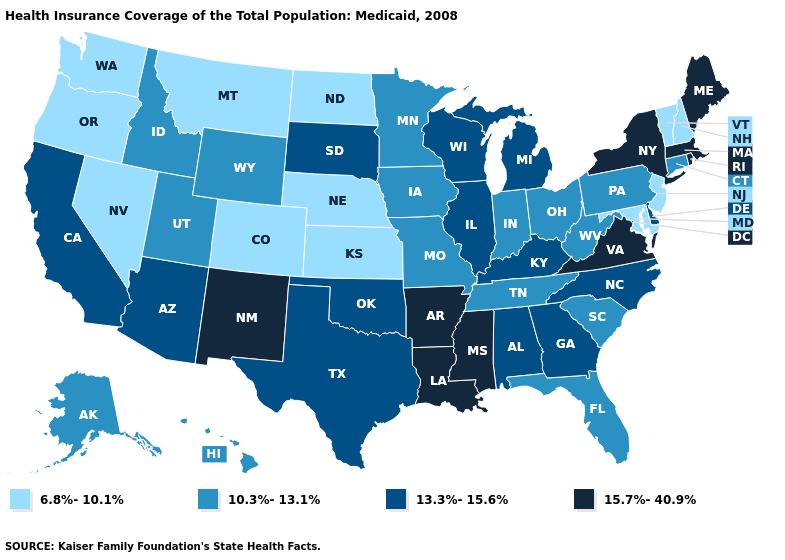What is the lowest value in the South?
Quick response, please. 6.8%-10.1%. What is the lowest value in the West?
Short answer required. 6.8%-10.1%. What is the value of Minnesota?
Give a very brief answer. 10.3%-13.1%. Does the first symbol in the legend represent the smallest category?
Be succinct. Yes. What is the value of Iowa?
Be succinct. 10.3%-13.1%. Name the states that have a value in the range 6.8%-10.1%?
Give a very brief answer. Colorado, Kansas, Maryland, Montana, Nebraska, Nevada, New Hampshire, New Jersey, North Dakota, Oregon, Vermont, Washington. Is the legend a continuous bar?
Keep it brief. No. Among the states that border Texas , which have the lowest value?
Short answer required. Oklahoma. Name the states that have a value in the range 6.8%-10.1%?
Concise answer only. Colorado, Kansas, Maryland, Montana, Nebraska, Nevada, New Hampshire, New Jersey, North Dakota, Oregon, Vermont, Washington. Name the states that have a value in the range 13.3%-15.6%?
Quick response, please. Alabama, Arizona, California, Delaware, Georgia, Illinois, Kentucky, Michigan, North Carolina, Oklahoma, South Dakota, Texas, Wisconsin. Which states hav the highest value in the West?
Write a very short answer. New Mexico. Name the states that have a value in the range 6.8%-10.1%?
Short answer required. Colorado, Kansas, Maryland, Montana, Nebraska, Nevada, New Hampshire, New Jersey, North Dakota, Oregon, Vermont, Washington. Name the states that have a value in the range 15.7%-40.9%?
Keep it brief. Arkansas, Louisiana, Maine, Massachusetts, Mississippi, New Mexico, New York, Rhode Island, Virginia. Does Illinois have the lowest value in the MidWest?
Keep it brief. No. 